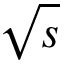Convert formula to latex. <formula><loc_0><loc_0><loc_500><loc_500>\sqrt { s }</formula> 